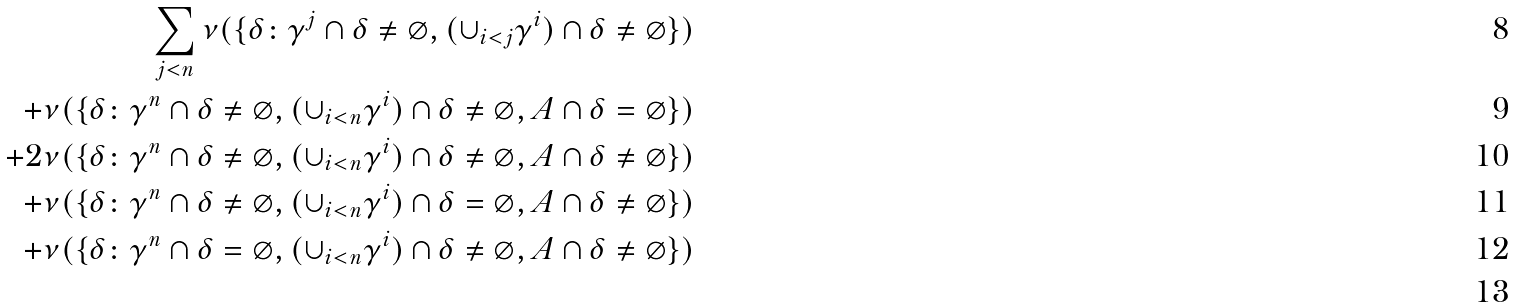<formula> <loc_0><loc_0><loc_500><loc_500>\sum _ { j < n } \nu ( \{ \delta \colon \gamma ^ { j } \cap \delta \neq \varnothing , ( \cup _ { i < j } \gamma ^ { i } ) \cap \delta \neq \varnothing \} ) \\ + \nu ( \{ \delta \colon \gamma ^ { n } \cap \delta \neq \varnothing , ( \cup _ { i < n } \gamma ^ { i } ) \cap \delta \neq \varnothing , A \cap \delta = \varnothing \} ) \\ + 2 \nu ( \{ \delta \colon \gamma ^ { n } \cap \delta \neq \varnothing , ( \cup _ { i < n } \gamma ^ { i } ) \cap \delta \neq \varnothing , A \cap \delta \neq \varnothing \} ) \\ + \nu ( \{ \delta \colon \gamma ^ { n } \cap \delta \neq \varnothing , ( \cup _ { i < n } \gamma ^ { i } ) \cap \delta = \varnothing , A \cap \delta \neq \varnothing \} ) \\ + \nu ( \{ \delta \colon \gamma ^ { n } \cap \delta = \varnothing , ( \cup _ { i < n } \gamma ^ { i } ) \cap \delta \neq \varnothing , A \cap \delta \neq \varnothing \} ) \\</formula> 